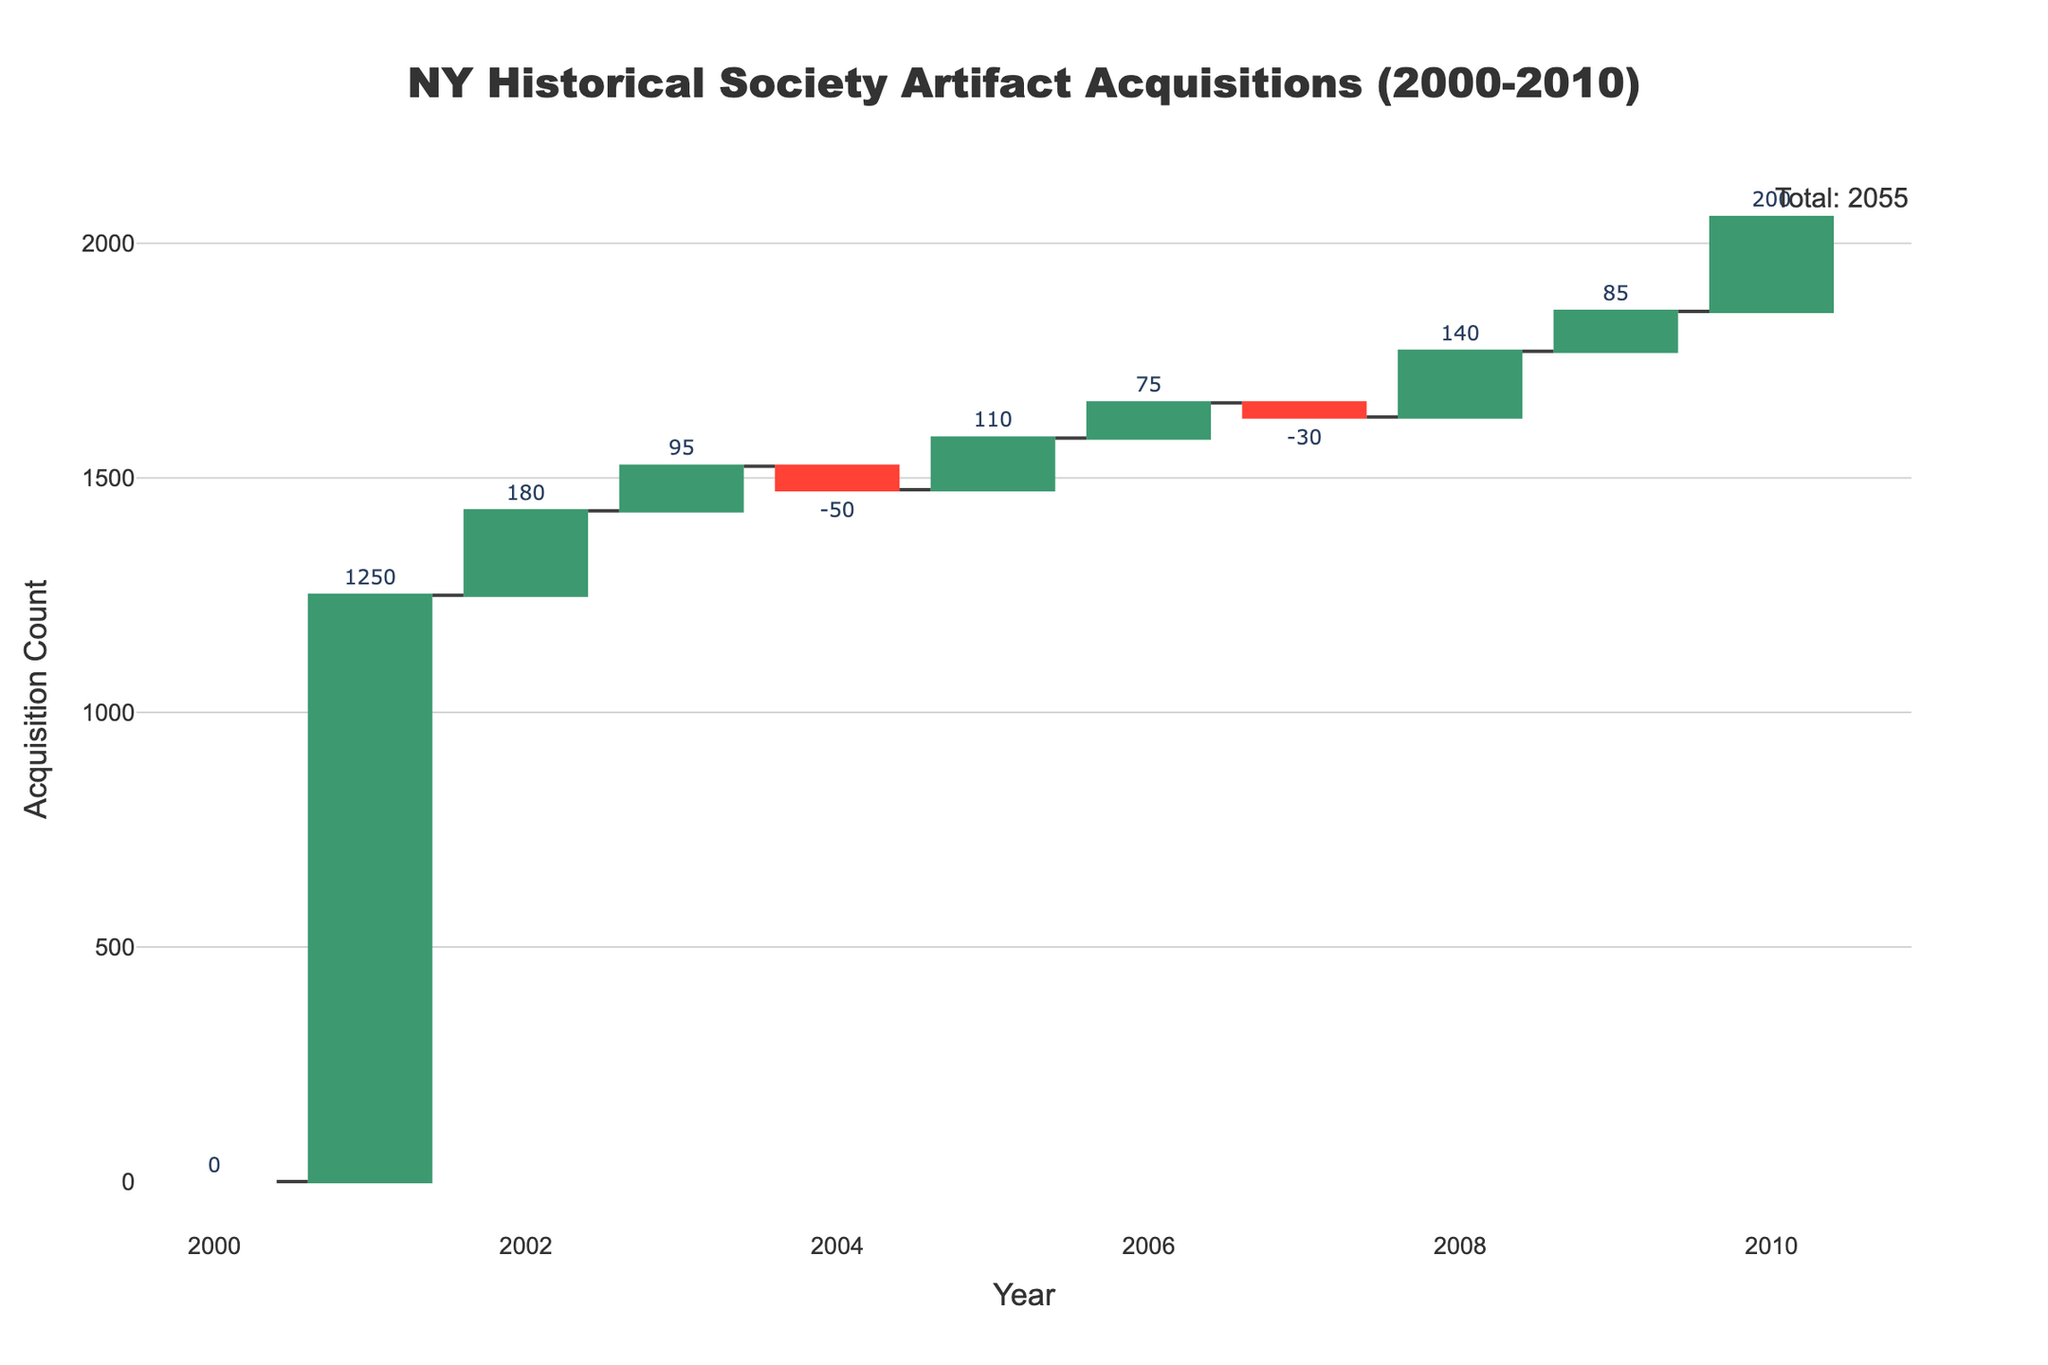how many types of artifacts were acquired in 2009? Refer to the figure to identify the year 2009 and the corresponding category; the category for 2009 is World War II Memorabilia, indicating only one type of artifact.
Answer: 1 What's the title of the chart? The title of the chart is typically displayed at the top, reading the exact text reveals it.
Answer: NY Historical Society Artifact Acquisitions (2000-2010) Which year saw the highest acquisition count? By looking at the highest positive value on the vertical bars, we can determine that 2001 has the highest count with 1250 acquisitions.
Answer: 2001 What is the total acquisition count by the end of 2010? Check the figure for the total shown at the end of the chart which is usually annotated; here, it's 2055.
Answer: 2055 Were there any years with a negative acquisition count? If so, which ones? Locate all the red (negative) bars in the chart, 2004 and 2007 show negative counts.
Answer: 2004 and 2007 What was the cumulative acquisition count by the end of 2005? Identify the year 2005, then check the cumulative total displayed for that year in the chart.
Answer: 1585 How does the acquisition count for Colonial Era Artifacts in 2002 compare to Civil War Memorabilia in 2003? Review the two corresponding years, 2002 has 180, and 2003 has 95; 2002 is greater.
Answer: 2002 is greater Calculate the average acquisition count from 2001 to 2010. Sum the acquisition counts for these years (1250 + 180 + 95 - 50 + 110 + 75 - 30 + 140 + 85 + 200) which equals 2055, then divide by 10 years.
Answer: 205.5 What category of artifacts was acquired in 2006? Locate the year 2006 in the chart and read the acquisition category name displayed.
Answer: Revolutionary War Items 